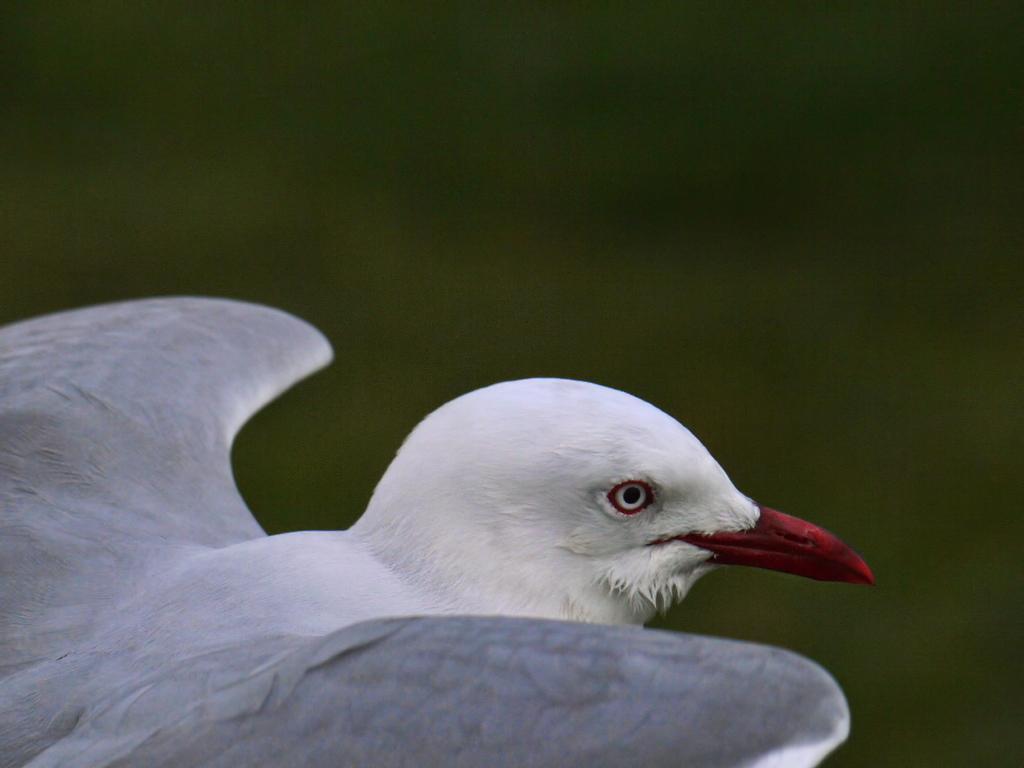Can you describe this image briefly? In this image I can see a white color bird facing towards the right side. The background is blurred. 